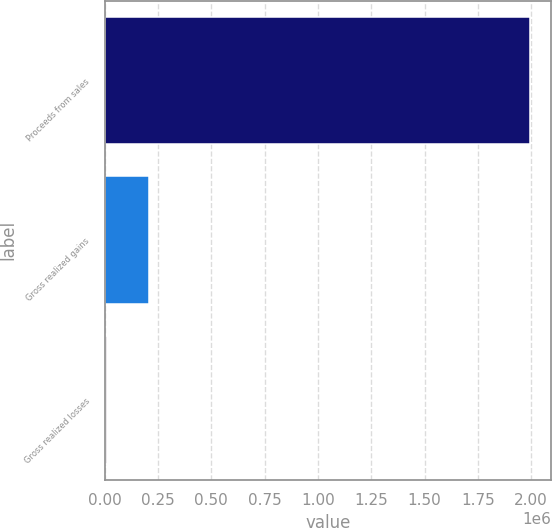<chart> <loc_0><loc_0><loc_500><loc_500><bar_chart><fcel>Proceeds from sales<fcel>Gross realized gains<fcel>Gross realized losses<nl><fcel>1.99537e+06<fcel>209150<fcel>10681<nl></chart> 